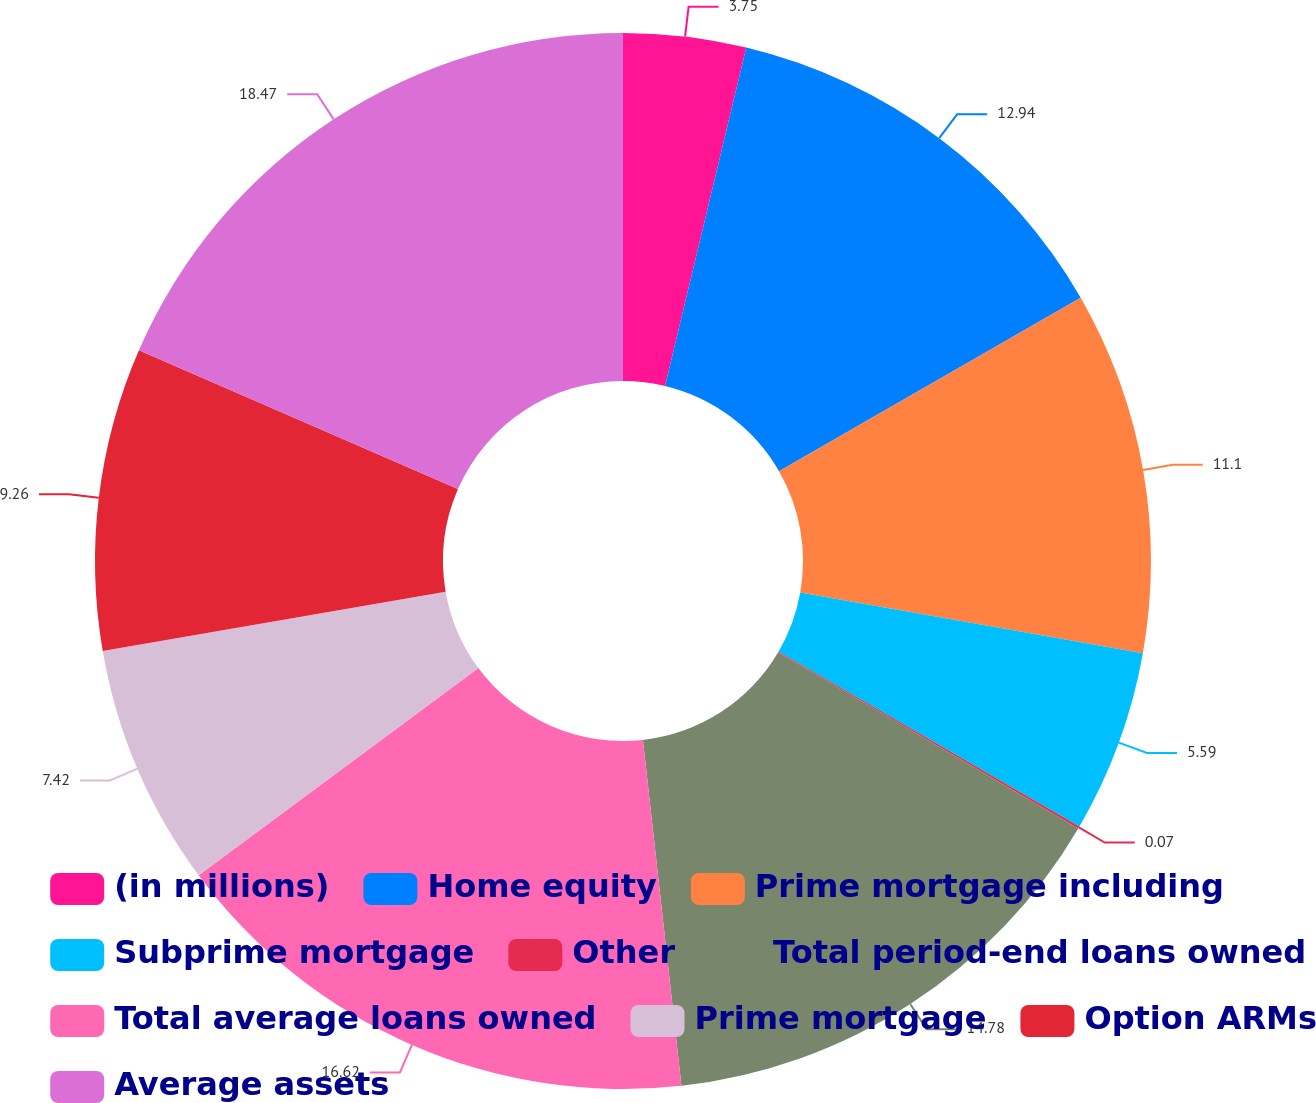<chart> <loc_0><loc_0><loc_500><loc_500><pie_chart><fcel>(in millions)<fcel>Home equity<fcel>Prime mortgage including<fcel>Subprime mortgage<fcel>Other<fcel>Total period-end loans owned<fcel>Total average loans owned<fcel>Prime mortgage<fcel>Option ARMs<fcel>Average assets<nl><fcel>3.75%<fcel>12.94%<fcel>11.1%<fcel>5.59%<fcel>0.07%<fcel>14.78%<fcel>16.62%<fcel>7.42%<fcel>9.26%<fcel>18.46%<nl></chart> 